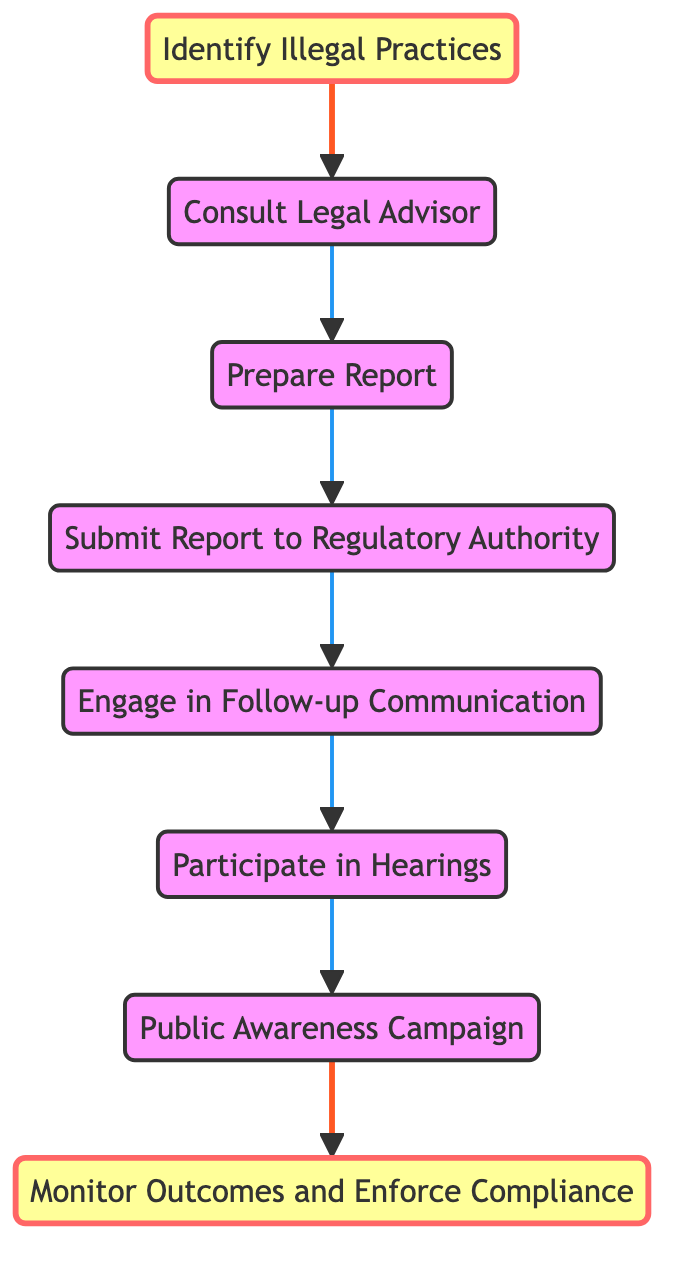What is the first step in the workflow? The first step in the workflow is to "Identify Illegal Practices," as indicated by the flow starting point in the diagram.
Answer: Identify Illegal Practices How many steps are in the workflow? The workflow consists of eight distinct steps, which can be counted from the nodes in the flowchart.
Answer: 8 What is the last step in the collaboration process? The last step in the workflow is "Monitor Outcomes and Enforce Compliance," which is the final node in the sequence.
Answer: Monitor Outcomes and Enforce Compliance Which step is immediately after "Submit Report to Regulatory Authority"? The step immediately following "Submit Report to Regulatory Authority" is "Engage in Follow-up Communication," as shown by the direct arrow connecting these two nodes in the flowchart.
Answer: Engage in Follow-up Communication What two steps are highlighted in the diagram? The two highlighted steps in the diagram are "Identify Illegal Practices" and "Monitor Outcomes and Enforce Compliance," which are marked to indicate their importance in the overall process.
Answer: Identify Illegal Practices, Monitor Outcomes and Enforce Compliance What is the purpose of engaging in follow-up communication? Engaging in follow-up communication allows coordination with the regulatory authority to provide additional information and track the investigation's status, as described in that step's explanation.
Answer: Provide additional information and track investigation’s status What is the relationship between "Participate in Hearings" and "Public Awareness Campaign"? The relationship between "Participate in Hearings" and "Public Awareness Campaign" is sequential; after participating in hearings, the next action is to work on raising public awareness, connected by the flow of the diagram.
Answer: Sequential connection Which steps involve communication with authorities? The steps that involve communication with authorities are "Submit Report to Regulatory Authority" and "Engage in Follow-up Communication," as these steps specifically mention interaction with regulatory bodies.
Answer: Submit Report to Regulatory Authority, Engage in Follow-up Communication What is the role of the legal advisor in the workflow? The role of the legal advisor in the workflow is to provide advice on sports law and necessary procedures, which is crucial before preparing the report, as indicated in the diagram.
Answer: Provide advice on sports law and procedures 